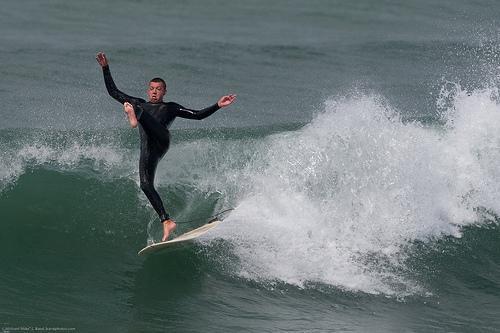How many people are in the photo?
Give a very brief answer. 1. How many of the man's limbs are in the air?
Give a very brief answer. 3. How many people are surfing?
Give a very brief answer. 1. 